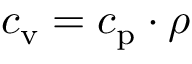<formula> <loc_0><loc_0><loc_500><loc_500>c _ { v } = c _ { p } \cdot \rho</formula> 